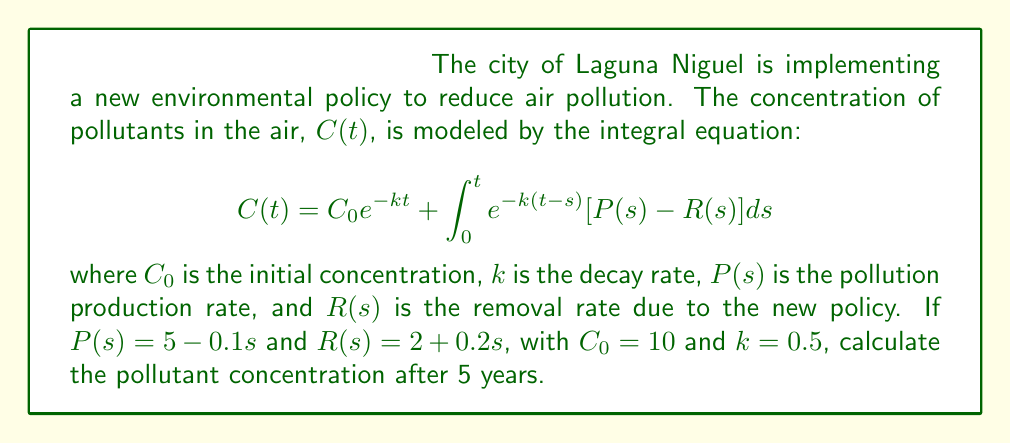Solve this math problem. To solve this problem, we'll follow these steps:

1) First, we need to simplify the integrand:
   $P(s) - R(s) = (5 - 0.1s) - (2 + 0.2s) = 3 - 0.3s$

2) Now, our integral equation becomes:
   $$C(5) = 10e^{-0.5(5)} + \int_0^5 e^{-0.5(5-s)}(3 - 0.3s)ds$$

3) Let's solve the integral:
   $$\int_0^5 e^{-0.5(5-s)}(3 - 0.3s)ds = \int_0^5 (3e^{0.5s-2.5} - 0.3se^{0.5s-2.5})ds$$

4) Using integration by parts for the second term:
   $$= 6e^{0.5s-2.5}|_0^5 - 0.6e^{0.5s-2.5}s|_0^5 + 0.6\int_0^5 e^{0.5s-2.5}ds$$

5) Evaluating the definite integrals:
   $$= 6(e^{2.5-2.5} - e^{0-2.5}) - 0.6(5e^{2.5-2.5} - 0e^{0-2.5}) + 1.2(e^{2.5-2.5} - e^{0-2.5})$$
   $$= 6(1 - e^{-2.5}) - 3 + 1.2(1 - e^{-2.5})$$
   $$= 7.2 - 7.2e^{-2.5} - 3 = 4.2 - 7.2e^{-2.5}$$

6) Now, let's calculate the first term of our original equation:
   $$10e^{-0.5(5)} = 10e^{-2.5} \approx 0.82$$

7) Adding the results from steps 5 and 6:
   $$C(5) = 0.82 + 4.2 - 7.2e^{-2.5} \approx 5.02 - 0.59 = 4.43$$
Answer: 4.43 